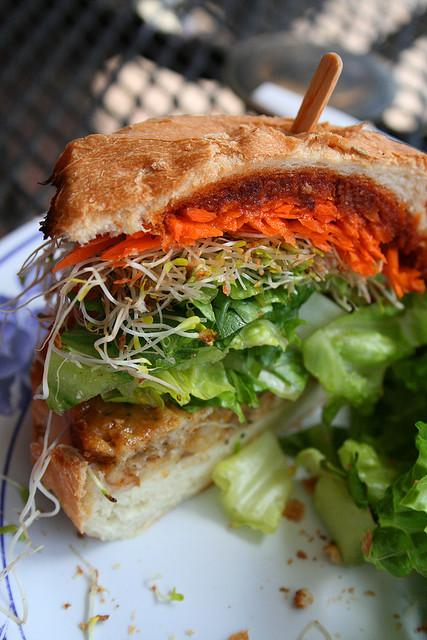This sandwich is probably being eaten in what kind of setting? Please explain your reasoning. outdoor. The light in the image is natural, and not artificial, and the table beneath it is a grated design. tables of this kind are used outdoors, so that rain can pass through them rather than pooling. 